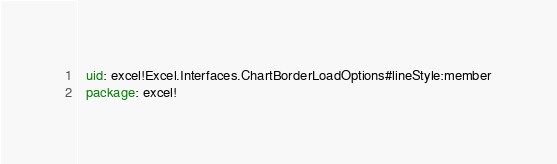Convert code to text. <code><loc_0><loc_0><loc_500><loc_500><_YAML_>  uid: excel!Excel.Interfaces.ChartBorderLoadOptions#lineStyle:member
  package: excel!</code> 